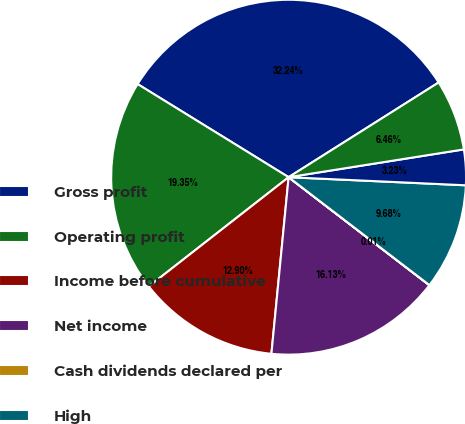<chart> <loc_0><loc_0><loc_500><loc_500><pie_chart><fcel>Gross profit<fcel>Operating profit<fcel>Income before cumulative<fcel>Net income<fcel>Cash dividends declared per<fcel>High<fcel>Low<fcel>Close<nl><fcel>32.24%<fcel>19.35%<fcel>12.9%<fcel>16.13%<fcel>0.01%<fcel>9.68%<fcel>3.23%<fcel>6.46%<nl></chart> 